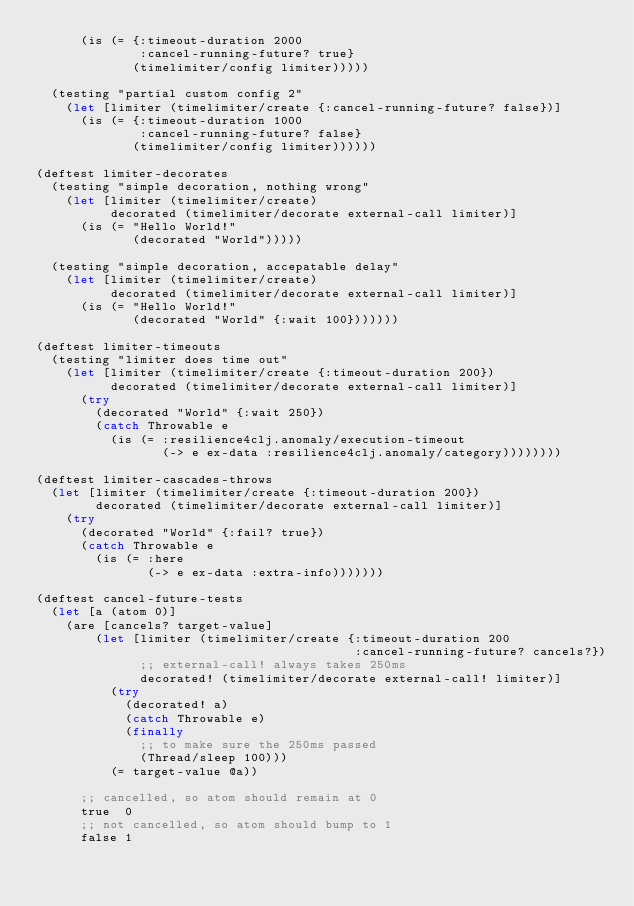<code> <loc_0><loc_0><loc_500><loc_500><_Clojure_>      (is (= {:timeout-duration 2000
              :cancel-running-future? true}
             (timelimiter/config limiter)))))

  (testing "partial custom config 2"
    (let [limiter (timelimiter/create {:cancel-running-future? false})]
      (is (= {:timeout-duration 1000
              :cancel-running-future? false}
             (timelimiter/config limiter))))))

(deftest limiter-decorates
  (testing "simple decoration, nothing wrong"
    (let [limiter (timelimiter/create)
          decorated (timelimiter/decorate external-call limiter)]
      (is (= "Hello World!"
             (decorated "World")))))

  (testing "simple decoration, accepatable delay"
    (let [limiter (timelimiter/create)
          decorated (timelimiter/decorate external-call limiter)]
      (is (= "Hello World!"
             (decorated "World" {:wait 100}))))))

(deftest limiter-timeouts
  (testing "limiter does time out"
    (let [limiter (timelimiter/create {:timeout-duration 200})
          decorated (timelimiter/decorate external-call limiter)]
      (try
        (decorated "World" {:wait 250})
        (catch Throwable e
          (is (= :resilience4clj.anomaly/execution-timeout
                 (-> e ex-data :resilience4clj.anomaly/category))))))))

(deftest limiter-cascades-throws
  (let [limiter (timelimiter/create {:timeout-duration 200})
        decorated (timelimiter/decorate external-call limiter)]
    (try
      (decorated "World" {:fail? true})
      (catch Throwable e
        (is (= :here
               (-> e ex-data :extra-info)))))))

(deftest cancel-future-tests
  (let [a (atom 0)]
    (are [cancels? target-value]
        (let [limiter (timelimiter/create {:timeout-duration 200
                                           :cancel-running-future? cancels?})
              ;; external-call! always takes 250ms
              decorated! (timelimiter/decorate external-call! limiter)]
          (try
            (decorated! a)
            (catch Throwable e)
            (finally
              ;; to make sure the 250ms passed
              (Thread/sleep 100)))
          (= target-value @a))

      ;; cancelled, so atom should remain at 0
      true  0
      ;; not cancelled, so atom should bump to 1
      false 1</code> 